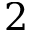<formula> <loc_0><loc_0><loc_500><loc_500>2</formula> 